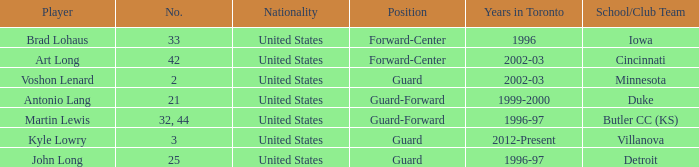How many schools did player number 3 play at? 1.0. 